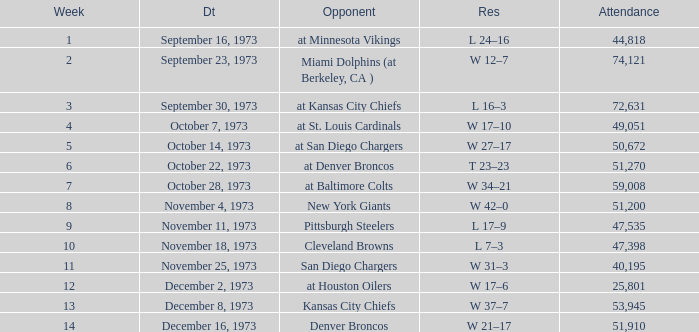What is the highest number in attendance against the game at Kansas City Chiefs? 72631.0. 